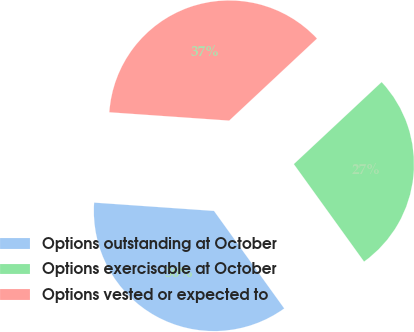<chart> <loc_0><loc_0><loc_500><loc_500><pie_chart><fcel>Options outstanding at October<fcel>Options exercisable at October<fcel>Options vested or expected to<nl><fcel>36.04%<fcel>27.03%<fcel>36.94%<nl></chart> 